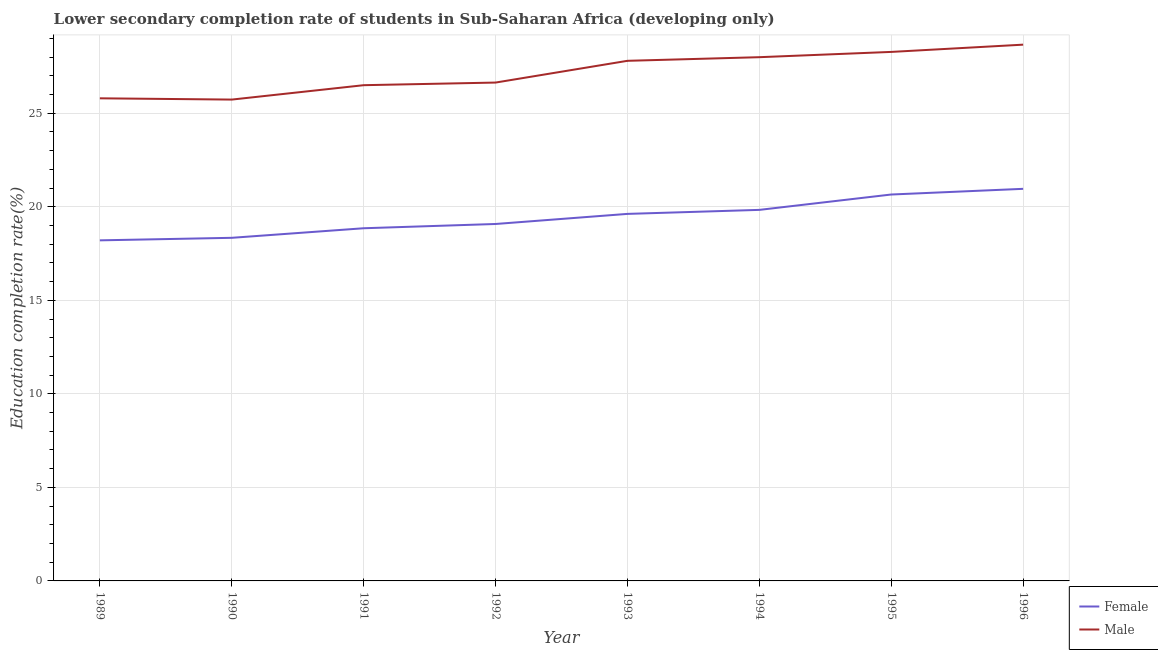How many different coloured lines are there?
Keep it short and to the point. 2. What is the education completion rate of male students in 1993?
Give a very brief answer. 27.8. Across all years, what is the maximum education completion rate of female students?
Your response must be concise. 20.96. Across all years, what is the minimum education completion rate of female students?
Your answer should be very brief. 18.21. In which year was the education completion rate of female students minimum?
Provide a short and direct response. 1989. What is the total education completion rate of female students in the graph?
Make the answer very short. 155.54. What is the difference between the education completion rate of male students in 1994 and that in 1995?
Provide a short and direct response. -0.28. What is the difference between the education completion rate of male students in 1995 and the education completion rate of female students in 1992?
Offer a terse response. 9.2. What is the average education completion rate of female students per year?
Ensure brevity in your answer.  19.44. In the year 1995, what is the difference between the education completion rate of male students and education completion rate of female students?
Your answer should be compact. 7.62. In how many years, is the education completion rate of male students greater than 9 %?
Keep it short and to the point. 8. What is the ratio of the education completion rate of female students in 1990 to that in 1993?
Your answer should be compact. 0.93. Is the education completion rate of male students in 1989 less than that in 1993?
Provide a succinct answer. Yes. Is the difference between the education completion rate of male students in 1993 and 1996 greater than the difference between the education completion rate of female students in 1993 and 1996?
Your answer should be very brief. Yes. What is the difference between the highest and the second highest education completion rate of female students?
Provide a short and direct response. 0.3. What is the difference between the highest and the lowest education completion rate of female students?
Your response must be concise. 2.75. Does the education completion rate of male students monotonically increase over the years?
Provide a succinct answer. No. Is the education completion rate of female students strictly greater than the education completion rate of male students over the years?
Make the answer very short. No. Is the education completion rate of male students strictly less than the education completion rate of female students over the years?
Give a very brief answer. No. What is the difference between two consecutive major ticks on the Y-axis?
Your answer should be very brief. 5. Are the values on the major ticks of Y-axis written in scientific E-notation?
Provide a short and direct response. No. Does the graph contain any zero values?
Provide a succinct answer. No. Does the graph contain grids?
Your answer should be very brief. Yes. How are the legend labels stacked?
Ensure brevity in your answer.  Vertical. What is the title of the graph?
Make the answer very short. Lower secondary completion rate of students in Sub-Saharan Africa (developing only). What is the label or title of the X-axis?
Your answer should be compact. Year. What is the label or title of the Y-axis?
Give a very brief answer. Education completion rate(%). What is the Education completion rate(%) of Female in 1989?
Provide a succinct answer. 18.21. What is the Education completion rate(%) in Male in 1989?
Keep it short and to the point. 25.8. What is the Education completion rate(%) of Female in 1990?
Keep it short and to the point. 18.34. What is the Education completion rate(%) in Male in 1990?
Keep it short and to the point. 25.73. What is the Education completion rate(%) in Female in 1991?
Offer a terse response. 18.85. What is the Education completion rate(%) of Male in 1991?
Your answer should be compact. 26.5. What is the Education completion rate(%) in Female in 1992?
Keep it short and to the point. 19.08. What is the Education completion rate(%) in Male in 1992?
Your answer should be very brief. 26.64. What is the Education completion rate(%) of Female in 1993?
Keep it short and to the point. 19.62. What is the Education completion rate(%) in Male in 1993?
Ensure brevity in your answer.  27.8. What is the Education completion rate(%) in Female in 1994?
Keep it short and to the point. 19.83. What is the Education completion rate(%) in Male in 1994?
Make the answer very short. 28. What is the Education completion rate(%) in Female in 1995?
Keep it short and to the point. 20.65. What is the Education completion rate(%) of Male in 1995?
Your answer should be very brief. 28.28. What is the Education completion rate(%) of Female in 1996?
Offer a very short reply. 20.96. What is the Education completion rate(%) in Male in 1996?
Offer a very short reply. 28.67. Across all years, what is the maximum Education completion rate(%) in Female?
Give a very brief answer. 20.96. Across all years, what is the maximum Education completion rate(%) in Male?
Make the answer very short. 28.67. Across all years, what is the minimum Education completion rate(%) in Female?
Make the answer very short. 18.21. Across all years, what is the minimum Education completion rate(%) in Male?
Your answer should be very brief. 25.73. What is the total Education completion rate(%) in Female in the graph?
Ensure brevity in your answer.  155.54. What is the total Education completion rate(%) of Male in the graph?
Make the answer very short. 217.4. What is the difference between the Education completion rate(%) of Female in 1989 and that in 1990?
Offer a very short reply. -0.14. What is the difference between the Education completion rate(%) in Male in 1989 and that in 1990?
Keep it short and to the point. 0.07. What is the difference between the Education completion rate(%) in Female in 1989 and that in 1991?
Make the answer very short. -0.65. What is the difference between the Education completion rate(%) in Male in 1989 and that in 1991?
Provide a short and direct response. -0.7. What is the difference between the Education completion rate(%) in Female in 1989 and that in 1992?
Give a very brief answer. -0.87. What is the difference between the Education completion rate(%) of Male in 1989 and that in 1992?
Your answer should be compact. -0.84. What is the difference between the Education completion rate(%) of Female in 1989 and that in 1993?
Provide a short and direct response. -1.41. What is the difference between the Education completion rate(%) of Male in 1989 and that in 1993?
Your response must be concise. -2. What is the difference between the Education completion rate(%) of Female in 1989 and that in 1994?
Offer a very short reply. -1.63. What is the difference between the Education completion rate(%) in Male in 1989 and that in 1994?
Keep it short and to the point. -2.2. What is the difference between the Education completion rate(%) in Female in 1989 and that in 1995?
Offer a terse response. -2.45. What is the difference between the Education completion rate(%) of Male in 1989 and that in 1995?
Offer a very short reply. -2.48. What is the difference between the Education completion rate(%) in Female in 1989 and that in 1996?
Ensure brevity in your answer.  -2.75. What is the difference between the Education completion rate(%) in Male in 1989 and that in 1996?
Ensure brevity in your answer.  -2.87. What is the difference between the Education completion rate(%) of Female in 1990 and that in 1991?
Make the answer very short. -0.51. What is the difference between the Education completion rate(%) in Male in 1990 and that in 1991?
Ensure brevity in your answer.  -0.77. What is the difference between the Education completion rate(%) in Female in 1990 and that in 1992?
Ensure brevity in your answer.  -0.74. What is the difference between the Education completion rate(%) in Male in 1990 and that in 1992?
Provide a succinct answer. -0.91. What is the difference between the Education completion rate(%) of Female in 1990 and that in 1993?
Your response must be concise. -1.28. What is the difference between the Education completion rate(%) of Male in 1990 and that in 1993?
Keep it short and to the point. -2.07. What is the difference between the Education completion rate(%) of Female in 1990 and that in 1994?
Make the answer very short. -1.49. What is the difference between the Education completion rate(%) of Male in 1990 and that in 1994?
Give a very brief answer. -2.27. What is the difference between the Education completion rate(%) of Female in 1990 and that in 1995?
Ensure brevity in your answer.  -2.31. What is the difference between the Education completion rate(%) in Male in 1990 and that in 1995?
Offer a very short reply. -2.55. What is the difference between the Education completion rate(%) of Female in 1990 and that in 1996?
Your response must be concise. -2.62. What is the difference between the Education completion rate(%) of Male in 1990 and that in 1996?
Ensure brevity in your answer.  -2.94. What is the difference between the Education completion rate(%) in Female in 1991 and that in 1992?
Offer a terse response. -0.23. What is the difference between the Education completion rate(%) of Male in 1991 and that in 1992?
Your answer should be very brief. -0.14. What is the difference between the Education completion rate(%) of Female in 1991 and that in 1993?
Offer a terse response. -0.77. What is the difference between the Education completion rate(%) of Male in 1991 and that in 1993?
Make the answer very short. -1.3. What is the difference between the Education completion rate(%) of Female in 1991 and that in 1994?
Ensure brevity in your answer.  -0.98. What is the difference between the Education completion rate(%) of Male in 1991 and that in 1994?
Give a very brief answer. -1.5. What is the difference between the Education completion rate(%) in Female in 1991 and that in 1995?
Keep it short and to the point. -1.8. What is the difference between the Education completion rate(%) in Male in 1991 and that in 1995?
Offer a terse response. -1.78. What is the difference between the Education completion rate(%) in Female in 1991 and that in 1996?
Give a very brief answer. -2.11. What is the difference between the Education completion rate(%) in Male in 1991 and that in 1996?
Your answer should be very brief. -2.17. What is the difference between the Education completion rate(%) in Female in 1992 and that in 1993?
Your answer should be very brief. -0.54. What is the difference between the Education completion rate(%) of Male in 1992 and that in 1993?
Ensure brevity in your answer.  -1.16. What is the difference between the Education completion rate(%) in Female in 1992 and that in 1994?
Ensure brevity in your answer.  -0.75. What is the difference between the Education completion rate(%) of Male in 1992 and that in 1994?
Your response must be concise. -1.36. What is the difference between the Education completion rate(%) of Female in 1992 and that in 1995?
Make the answer very short. -1.58. What is the difference between the Education completion rate(%) in Male in 1992 and that in 1995?
Ensure brevity in your answer.  -1.64. What is the difference between the Education completion rate(%) of Female in 1992 and that in 1996?
Provide a succinct answer. -1.88. What is the difference between the Education completion rate(%) in Male in 1992 and that in 1996?
Give a very brief answer. -2.03. What is the difference between the Education completion rate(%) of Female in 1993 and that in 1994?
Provide a short and direct response. -0.21. What is the difference between the Education completion rate(%) of Male in 1993 and that in 1994?
Provide a short and direct response. -0.19. What is the difference between the Education completion rate(%) of Female in 1993 and that in 1995?
Offer a very short reply. -1.04. What is the difference between the Education completion rate(%) of Male in 1993 and that in 1995?
Give a very brief answer. -0.48. What is the difference between the Education completion rate(%) in Female in 1993 and that in 1996?
Provide a succinct answer. -1.34. What is the difference between the Education completion rate(%) in Male in 1993 and that in 1996?
Provide a succinct answer. -0.86. What is the difference between the Education completion rate(%) in Female in 1994 and that in 1995?
Give a very brief answer. -0.82. What is the difference between the Education completion rate(%) of Male in 1994 and that in 1995?
Give a very brief answer. -0.28. What is the difference between the Education completion rate(%) of Female in 1994 and that in 1996?
Offer a terse response. -1.13. What is the difference between the Education completion rate(%) in Male in 1994 and that in 1996?
Your answer should be very brief. -0.67. What is the difference between the Education completion rate(%) in Female in 1995 and that in 1996?
Offer a terse response. -0.3. What is the difference between the Education completion rate(%) of Male in 1995 and that in 1996?
Your answer should be compact. -0.39. What is the difference between the Education completion rate(%) of Female in 1989 and the Education completion rate(%) of Male in 1990?
Give a very brief answer. -7.52. What is the difference between the Education completion rate(%) of Female in 1989 and the Education completion rate(%) of Male in 1991?
Provide a short and direct response. -8.29. What is the difference between the Education completion rate(%) of Female in 1989 and the Education completion rate(%) of Male in 1992?
Make the answer very short. -8.43. What is the difference between the Education completion rate(%) in Female in 1989 and the Education completion rate(%) in Male in 1993?
Your answer should be very brief. -9.6. What is the difference between the Education completion rate(%) in Female in 1989 and the Education completion rate(%) in Male in 1994?
Make the answer very short. -9.79. What is the difference between the Education completion rate(%) in Female in 1989 and the Education completion rate(%) in Male in 1995?
Your answer should be compact. -10.07. What is the difference between the Education completion rate(%) of Female in 1989 and the Education completion rate(%) of Male in 1996?
Your answer should be very brief. -10.46. What is the difference between the Education completion rate(%) in Female in 1990 and the Education completion rate(%) in Male in 1991?
Provide a short and direct response. -8.16. What is the difference between the Education completion rate(%) of Female in 1990 and the Education completion rate(%) of Male in 1992?
Make the answer very short. -8.3. What is the difference between the Education completion rate(%) in Female in 1990 and the Education completion rate(%) in Male in 1993?
Offer a very short reply. -9.46. What is the difference between the Education completion rate(%) in Female in 1990 and the Education completion rate(%) in Male in 1994?
Your answer should be compact. -9.65. What is the difference between the Education completion rate(%) in Female in 1990 and the Education completion rate(%) in Male in 1995?
Offer a very short reply. -9.94. What is the difference between the Education completion rate(%) of Female in 1990 and the Education completion rate(%) of Male in 1996?
Ensure brevity in your answer.  -10.32. What is the difference between the Education completion rate(%) of Female in 1991 and the Education completion rate(%) of Male in 1992?
Your answer should be compact. -7.79. What is the difference between the Education completion rate(%) in Female in 1991 and the Education completion rate(%) in Male in 1993?
Give a very brief answer. -8.95. What is the difference between the Education completion rate(%) in Female in 1991 and the Education completion rate(%) in Male in 1994?
Keep it short and to the point. -9.14. What is the difference between the Education completion rate(%) of Female in 1991 and the Education completion rate(%) of Male in 1995?
Your answer should be very brief. -9.43. What is the difference between the Education completion rate(%) in Female in 1991 and the Education completion rate(%) in Male in 1996?
Your answer should be very brief. -9.81. What is the difference between the Education completion rate(%) of Female in 1992 and the Education completion rate(%) of Male in 1993?
Ensure brevity in your answer.  -8.72. What is the difference between the Education completion rate(%) in Female in 1992 and the Education completion rate(%) in Male in 1994?
Your answer should be compact. -8.92. What is the difference between the Education completion rate(%) in Female in 1992 and the Education completion rate(%) in Male in 1995?
Make the answer very short. -9.2. What is the difference between the Education completion rate(%) of Female in 1992 and the Education completion rate(%) of Male in 1996?
Ensure brevity in your answer.  -9.59. What is the difference between the Education completion rate(%) in Female in 1993 and the Education completion rate(%) in Male in 1994?
Make the answer very short. -8.38. What is the difference between the Education completion rate(%) of Female in 1993 and the Education completion rate(%) of Male in 1995?
Give a very brief answer. -8.66. What is the difference between the Education completion rate(%) of Female in 1993 and the Education completion rate(%) of Male in 1996?
Your answer should be compact. -9.05. What is the difference between the Education completion rate(%) of Female in 1994 and the Education completion rate(%) of Male in 1995?
Your answer should be very brief. -8.44. What is the difference between the Education completion rate(%) of Female in 1994 and the Education completion rate(%) of Male in 1996?
Offer a very short reply. -8.83. What is the difference between the Education completion rate(%) in Female in 1995 and the Education completion rate(%) in Male in 1996?
Provide a succinct answer. -8.01. What is the average Education completion rate(%) of Female per year?
Offer a very short reply. 19.44. What is the average Education completion rate(%) of Male per year?
Ensure brevity in your answer.  27.18. In the year 1989, what is the difference between the Education completion rate(%) of Female and Education completion rate(%) of Male?
Make the answer very short. -7.59. In the year 1990, what is the difference between the Education completion rate(%) in Female and Education completion rate(%) in Male?
Offer a very short reply. -7.39. In the year 1991, what is the difference between the Education completion rate(%) in Female and Education completion rate(%) in Male?
Give a very brief answer. -7.65. In the year 1992, what is the difference between the Education completion rate(%) of Female and Education completion rate(%) of Male?
Keep it short and to the point. -7.56. In the year 1993, what is the difference between the Education completion rate(%) of Female and Education completion rate(%) of Male?
Give a very brief answer. -8.18. In the year 1994, what is the difference between the Education completion rate(%) in Female and Education completion rate(%) in Male?
Offer a very short reply. -8.16. In the year 1995, what is the difference between the Education completion rate(%) of Female and Education completion rate(%) of Male?
Your response must be concise. -7.62. In the year 1996, what is the difference between the Education completion rate(%) in Female and Education completion rate(%) in Male?
Make the answer very short. -7.71. What is the ratio of the Education completion rate(%) in Female in 1989 to that in 1990?
Make the answer very short. 0.99. What is the ratio of the Education completion rate(%) of Female in 1989 to that in 1991?
Make the answer very short. 0.97. What is the ratio of the Education completion rate(%) of Male in 1989 to that in 1991?
Give a very brief answer. 0.97. What is the ratio of the Education completion rate(%) in Female in 1989 to that in 1992?
Your answer should be very brief. 0.95. What is the ratio of the Education completion rate(%) of Male in 1989 to that in 1992?
Provide a succinct answer. 0.97. What is the ratio of the Education completion rate(%) in Female in 1989 to that in 1993?
Offer a very short reply. 0.93. What is the ratio of the Education completion rate(%) of Male in 1989 to that in 1993?
Provide a short and direct response. 0.93. What is the ratio of the Education completion rate(%) in Female in 1989 to that in 1994?
Keep it short and to the point. 0.92. What is the ratio of the Education completion rate(%) in Male in 1989 to that in 1994?
Your answer should be compact. 0.92. What is the ratio of the Education completion rate(%) in Female in 1989 to that in 1995?
Offer a very short reply. 0.88. What is the ratio of the Education completion rate(%) of Male in 1989 to that in 1995?
Provide a short and direct response. 0.91. What is the ratio of the Education completion rate(%) of Female in 1989 to that in 1996?
Your response must be concise. 0.87. What is the ratio of the Education completion rate(%) in Male in 1989 to that in 1996?
Your answer should be very brief. 0.9. What is the ratio of the Education completion rate(%) in Female in 1990 to that in 1991?
Your response must be concise. 0.97. What is the ratio of the Education completion rate(%) in Female in 1990 to that in 1992?
Make the answer very short. 0.96. What is the ratio of the Education completion rate(%) of Male in 1990 to that in 1992?
Offer a very short reply. 0.97. What is the ratio of the Education completion rate(%) of Female in 1990 to that in 1993?
Your answer should be very brief. 0.93. What is the ratio of the Education completion rate(%) in Male in 1990 to that in 1993?
Your response must be concise. 0.93. What is the ratio of the Education completion rate(%) in Female in 1990 to that in 1994?
Offer a terse response. 0.92. What is the ratio of the Education completion rate(%) in Male in 1990 to that in 1994?
Your answer should be very brief. 0.92. What is the ratio of the Education completion rate(%) in Female in 1990 to that in 1995?
Keep it short and to the point. 0.89. What is the ratio of the Education completion rate(%) of Male in 1990 to that in 1995?
Your response must be concise. 0.91. What is the ratio of the Education completion rate(%) of Female in 1990 to that in 1996?
Provide a succinct answer. 0.88. What is the ratio of the Education completion rate(%) in Male in 1990 to that in 1996?
Ensure brevity in your answer.  0.9. What is the ratio of the Education completion rate(%) of Female in 1991 to that in 1992?
Your answer should be compact. 0.99. What is the ratio of the Education completion rate(%) of Female in 1991 to that in 1993?
Your response must be concise. 0.96. What is the ratio of the Education completion rate(%) of Male in 1991 to that in 1993?
Provide a succinct answer. 0.95. What is the ratio of the Education completion rate(%) of Female in 1991 to that in 1994?
Ensure brevity in your answer.  0.95. What is the ratio of the Education completion rate(%) of Male in 1991 to that in 1994?
Provide a succinct answer. 0.95. What is the ratio of the Education completion rate(%) of Female in 1991 to that in 1995?
Offer a terse response. 0.91. What is the ratio of the Education completion rate(%) in Male in 1991 to that in 1995?
Provide a short and direct response. 0.94. What is the ratio of the Education completion rate(%) in Female in 1991 to that in 1996?
Keep it short and to the point. 0.9. What is the ratio of the Education completion rate(%) of Male in 1991 to that in 1996?
Offer a terse response. 0.92. What is the ratio of the Education completion rate(%) in Female in 1992 to that in 1993?
Provide a succinct answer. 0.97. What is the ratio of the Education completion rate(%) of Male in 1992 to that in 1993?
Offer a very short reply. 0.96. What is the ratio of the Education completion rate(%) in Female in 1992 to that in 1994?
Your response must be concise. 0.96. What is the ratio of the Education completion rate(%) of Male in 1992 to that in 1994?
Your response must be concise. 0.95. What is the ratio of the Education completion rate(%) in Female in 1992 to that in 1995?
Ensure brevity in your answer.  0.92. What is the ratio of the Education completion rate(%) in Male in 1992 to that in 1995?
Keep it short and to the point. 0.94. What is the ratio of the Education completion rate(%) of Female in 1992 to that in 1996?
Offer a very short reply. 0.91. What is the ratio of the Education completion rate(%) in Male in 1992 to that in 1996?
Your answer should be very brief. 0.93. What is the ratio of the Education completion rate(%) of Male in 1993 to that in 1994?
Your response must be concise. 0.99. What is the ratio of the Education completion rate(%) in Female in 1993 to that in 1995?
Keep it short and to the point. 0.95. What is the ratio of the Education completion rate(%) of Male in 1993 to that in 1995?
Your answer should be compact. 0.98. What is the ratio of the Education completion rate(%) in Female in 1993 to that in 1996?
Provide a succinct answer. 0.94. What is the ratio of the Education completion rate(%) of Male in 1993 to that in 1996?
Offer a terse response. 0.97. What is the ratio of the Education completion rate(%) of Female in 1994 to that in 1995?
Keep it short and to the point. 0.96. What is the ratio of the Education completion rate(%) of Male in 1994 to that in 1995?
Provide a short and direct response. 0.99. What is the ratio of the Education completion rate(%) in Female in 1994 to that in 1996?
Provide a succinct answer. 0.95. What is the ratio of the Education completion rate(%) in Male in 1994 to that in 1996?
Provide a short and direct response. 0.98. What is the ratio of the Education completion rate(%) in Female in 1995 to that in 1996?
Make the answer very short. 0.99. What is the ratio of the Education completion rate(%) in Male in 1995 to that in 1996?
Your answer should be compact. 0.99. What is the difference between the highest and the second highest Education completion rate(%) of Female?
Your answer should be very brief. 0.3. What is the difference between the highest and the second highest Education completion rate(%) of Male?
Offer a terse response. 0.39. What is the difference between the highest and the lowest Education completion rate(%) of Female?
Provide a succinct answer. 2.75. What is the difference between the highest and the lowest Education completion rate(%) in Male?
Provide a short and direct response. 2.94. 